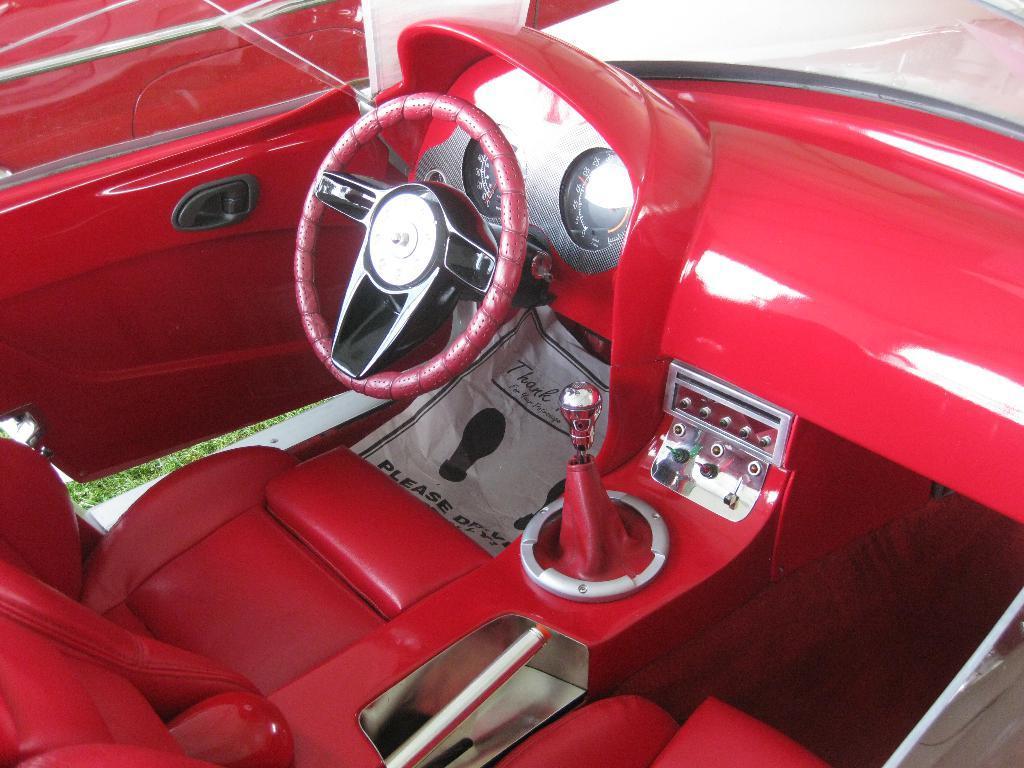How would you summarize this image in a sentence or two? In this image I can see the red color car. Inside the car I can see the steering, gear rod and the seats. To the left I can see the grass and the door of the car. 